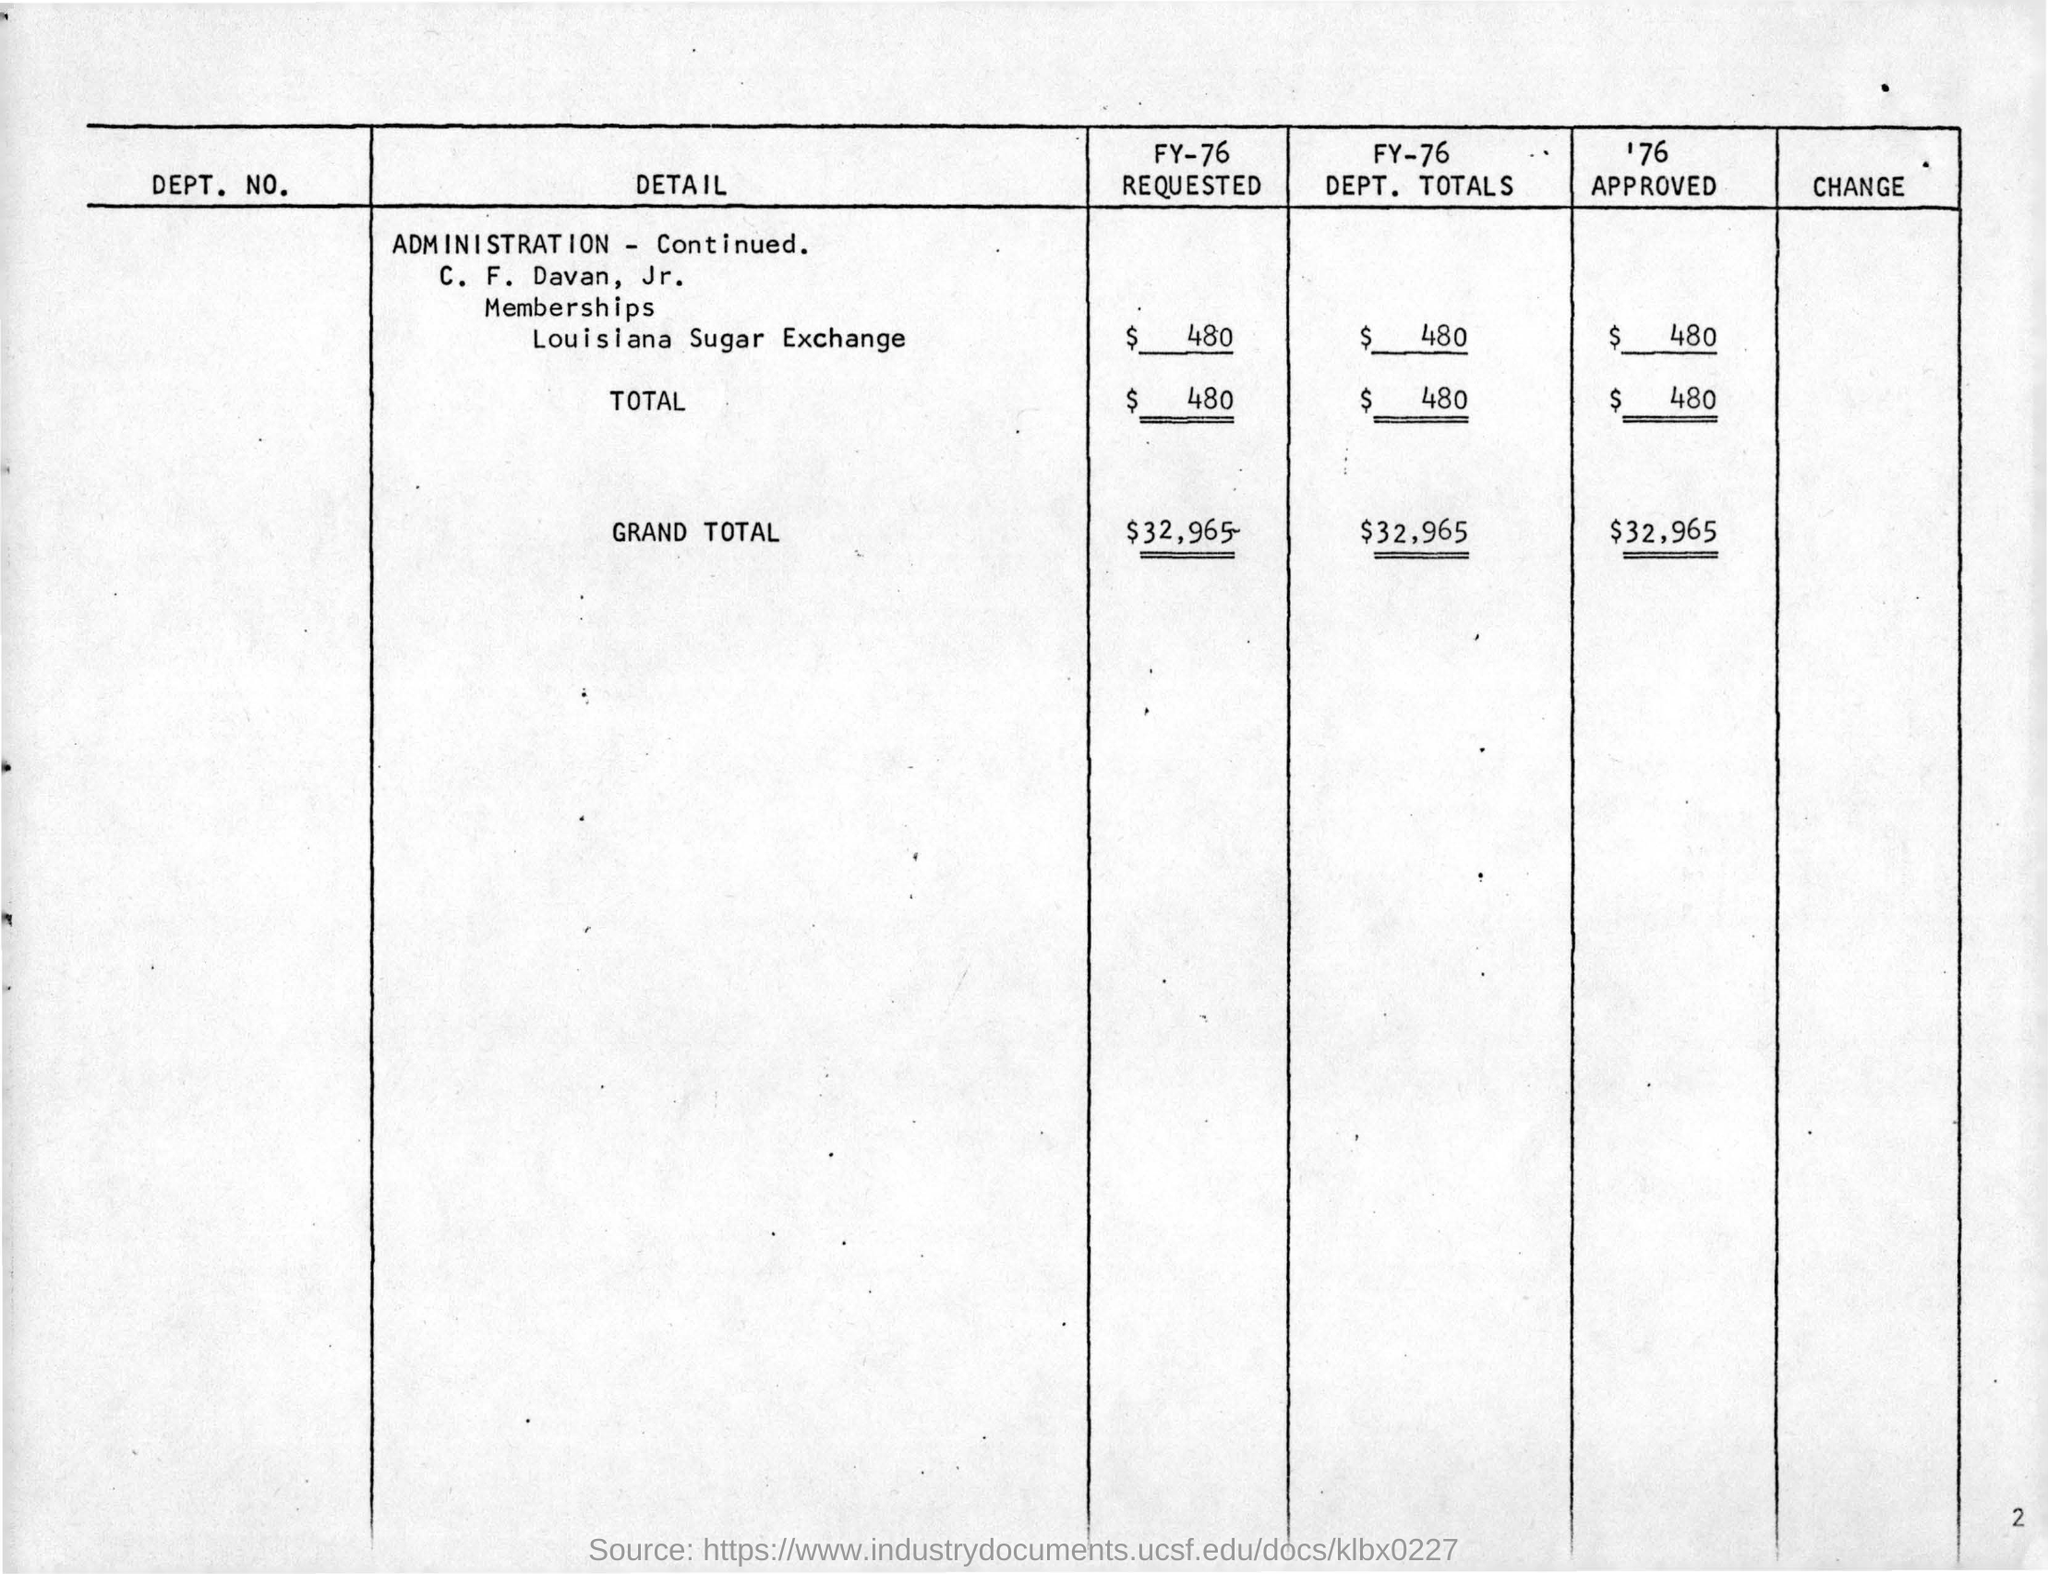What is the Page Number?
Give a very brief answer. 2. 